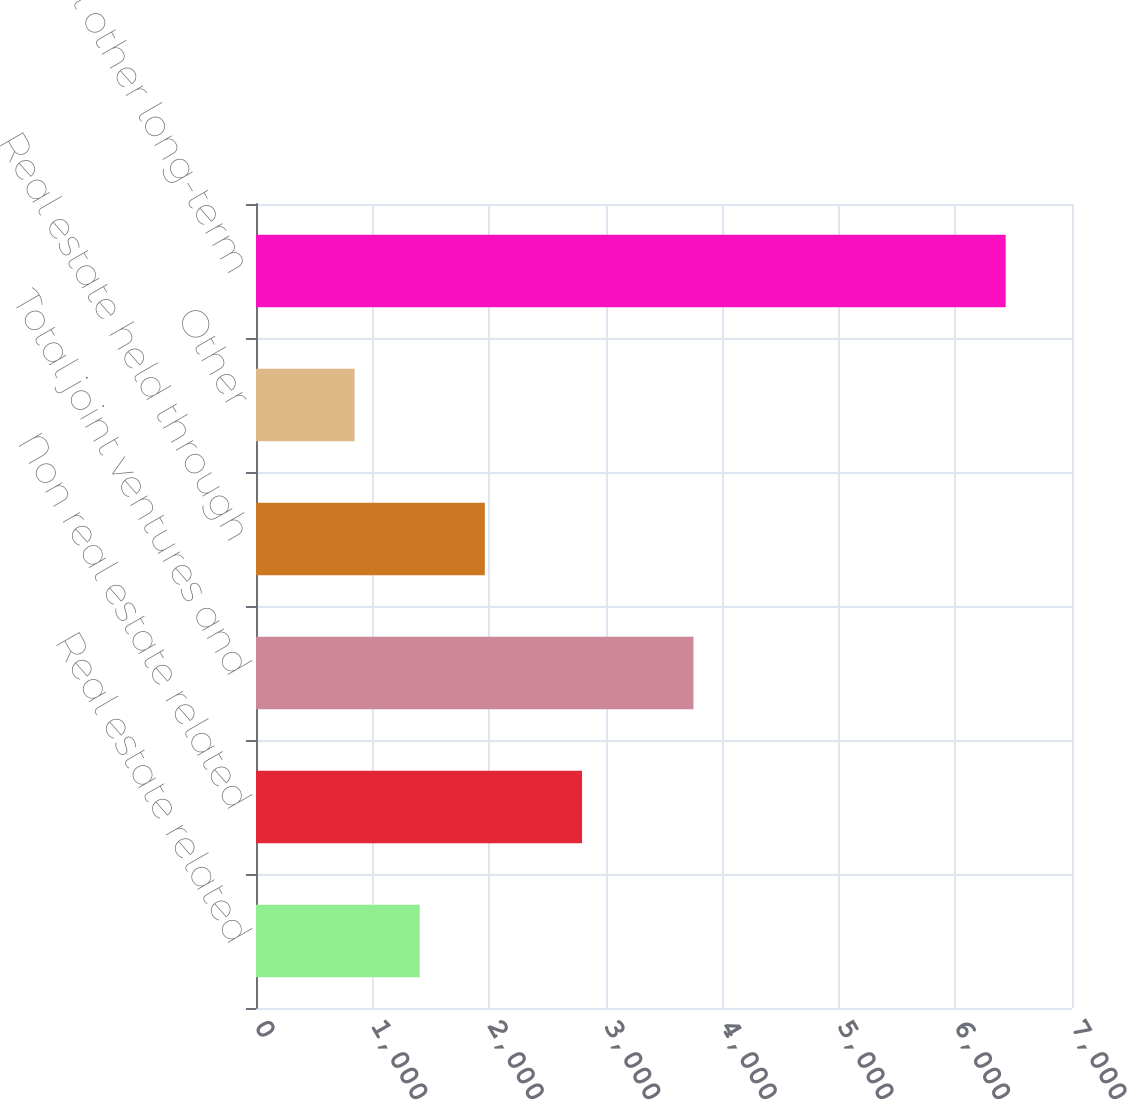Convert chart to OTSL. <chart><loc_0><loc_0><loc_500><loc_500><bar_chart><fcel>Real estate related<fcel>Non real estate related<fcel>Total joint ventures and<fcel>Real estate held through<fcel>Other<fcel>Total other long-term<nl><fcel>1404.5<fcel>2797<fcel>3753<fcel>1963<fcel>846<fcel>6431<nl></chart> 